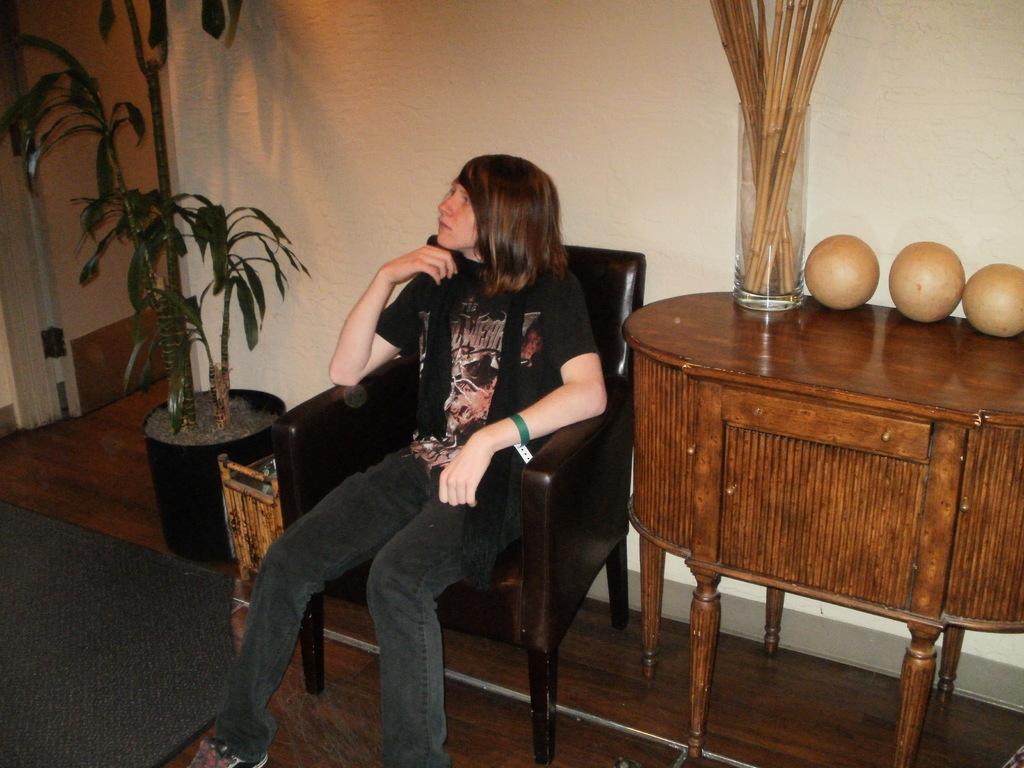In one or two sentences, can you explain what this image depicts? As we can see in the image, there is a white color wall, plant, chair and a girl sitting on chair. Beside her there are sticks and balls 